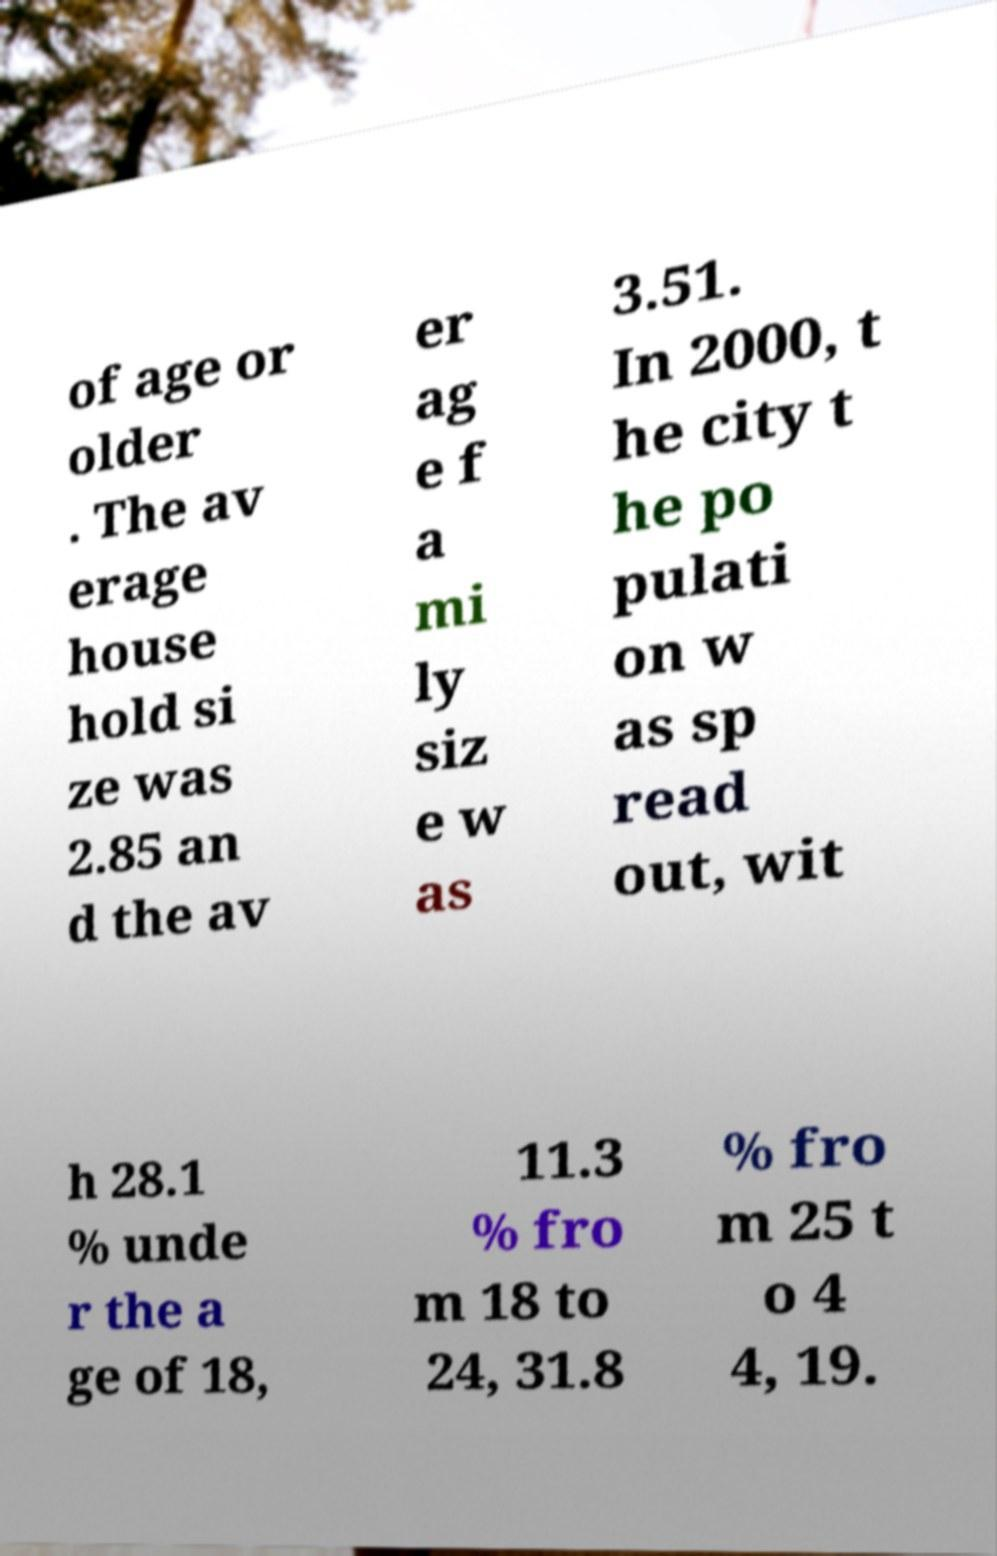Could you assist in decoding the text presented in this image and type it out clearly? of age or older . The av erage house hold si ze was 2.85 an d the av er ag e f a mi ly siz e w as 3.51. In 2000, t he city t he po pulati on w as sp read out, wit h 28.1 % unde r the a ge of 18, 11.3 % fro m 18 to 24, 31.8 % fro m 25 t o 4 4, 19. 